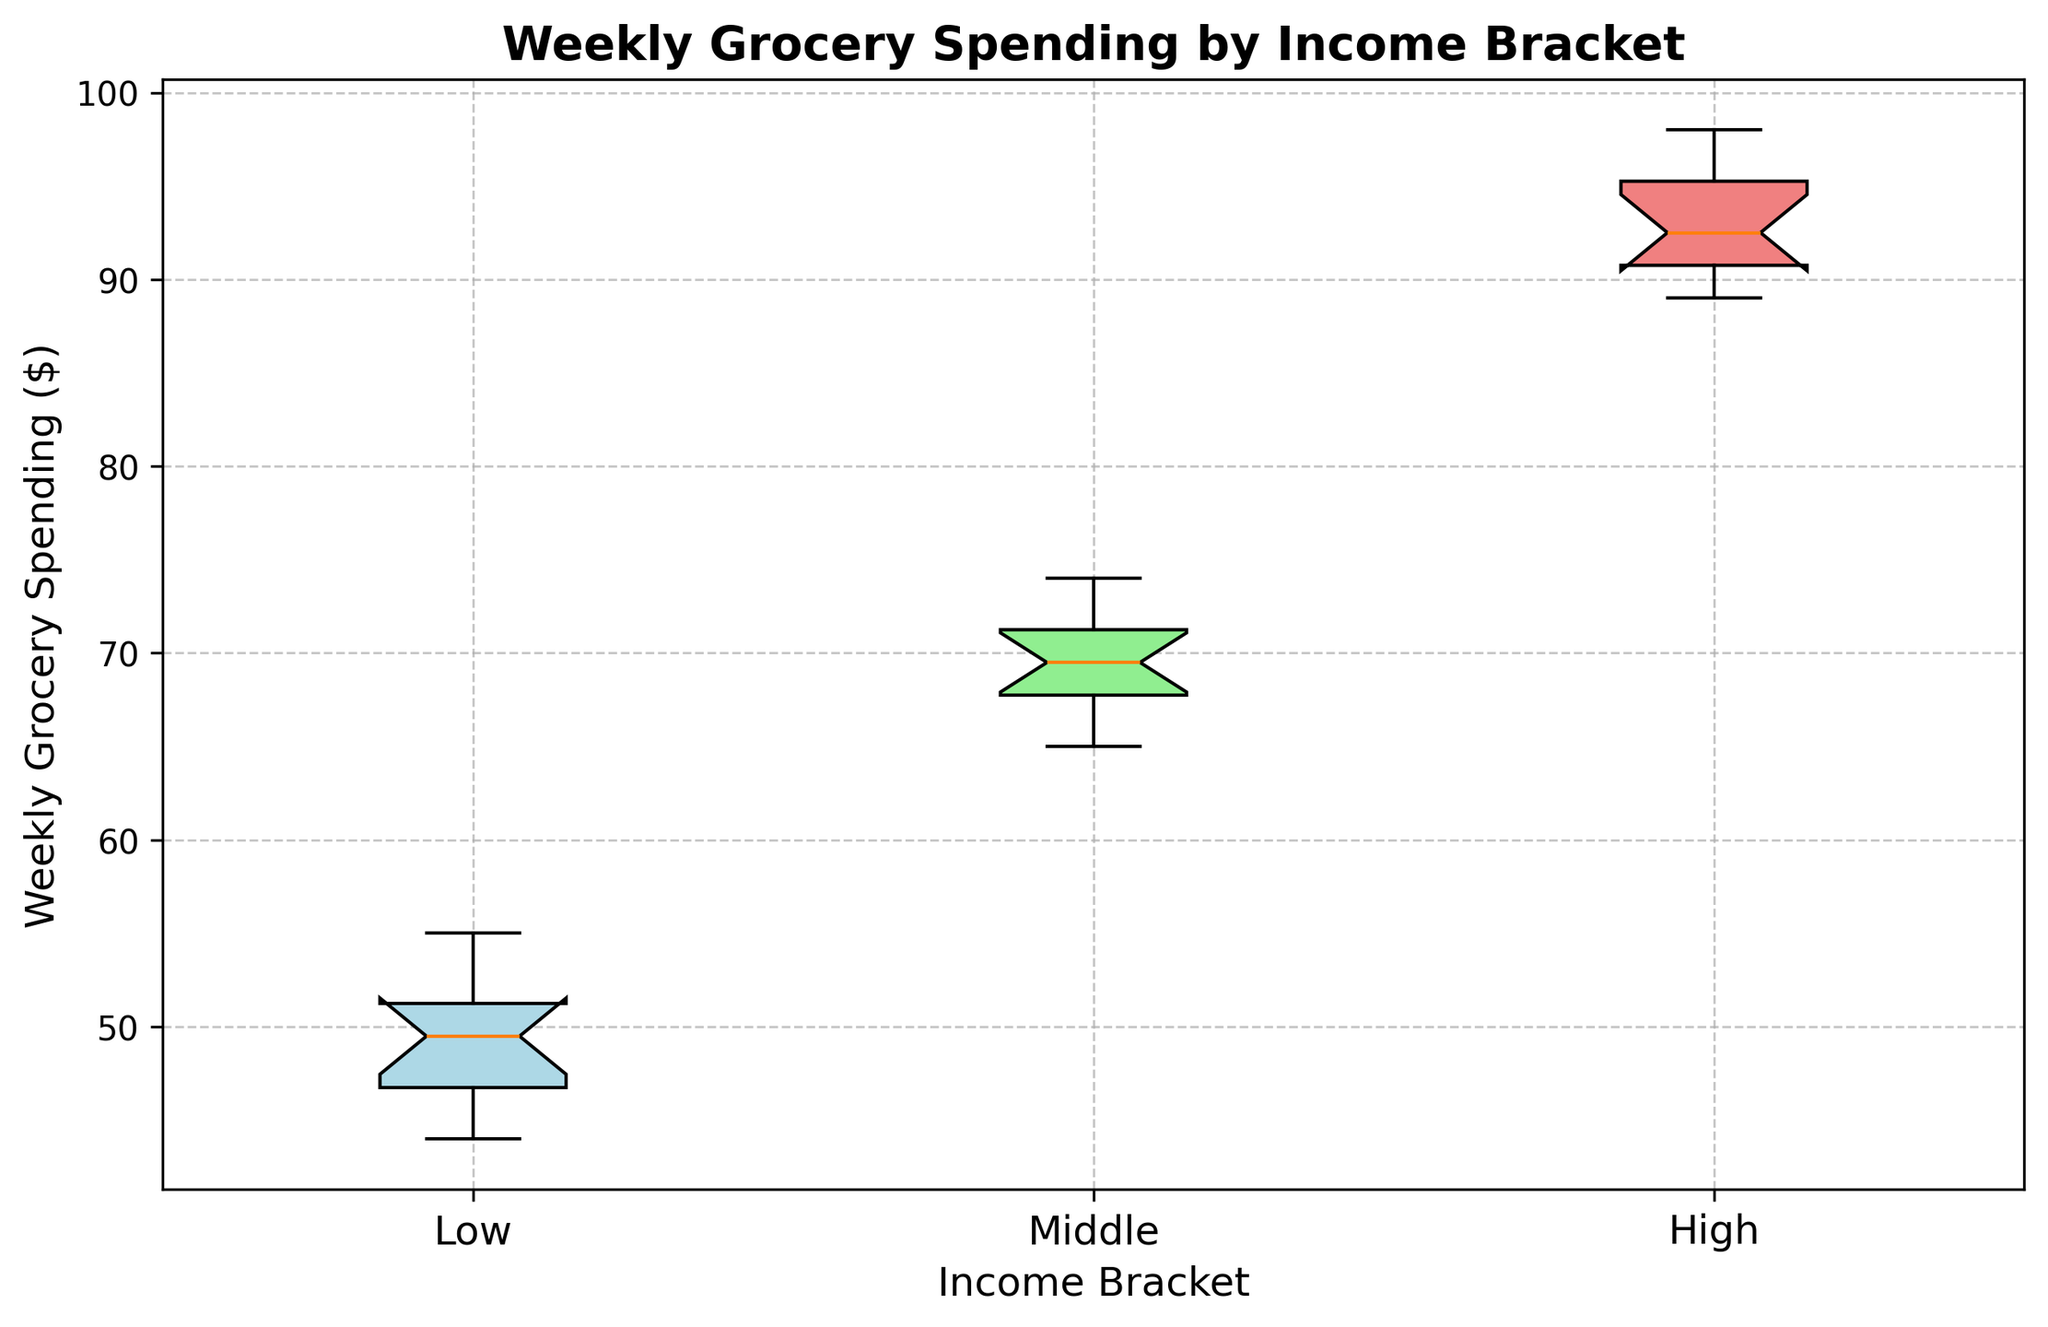What's the median weekly grocery spending for each income bracket? First, find the middle value for each group's data. If the number of data points is odd, the median is the middle value. If even, it's the average of the two middle values. For 'Low' (44, 45, 46, 47, 48, 49, 50, 50, 51, 52, 53, 55), the median is 49.5 (average of 49 and 50). For 'Middle' (65, 66, 67, 68, 68, 69, 70, 71, 71, 72, 73, 74), the median is 69.5. For 'High' (89, 90, 90, 91, 91, 92, 93, 94, 95, 96, 97, 98), the median is 92.5.
Answer: Low: 49.5, Middle: 69.5, High: 92.5 Which income bracket has the highest maximum spending? Look at the top values of the whiskers or outliers for each group. 'High' income bracket extends to 98, which is higher than the maximum values for 'Low' (55) and 'Middle' (74) income brackets.
Answer: High What's the interquartile range (IQR) for the Middle-income bracket? The IQR is the difference between the third quartile (Q3) and the first quartile (Q1). For the 'Middle' group, Q1 is approximately 67, and Q3 is approximately 72. So, IQR = 72 - 67.
Answer: 5 Compared to the Low-income bracket, is the range of weekly grocery spending larger for the High-income bracket? Calculate the range (maximum - minimum) for both. 'Low' has a range of 55 - 44 = 11. 'High' has a range of 98 - 89 = 9.
Answer: No Which income bracket has the smallest spread, or variance, in weekly grocery spending? Look at the box widths: the 'Low' income bracket has a narrower box compared to 'Middle' and 'High', indicating lower variability.
Answer: Low Which income bracket has the larger median weekly grocery spending, Middle or High? Examine the central line within each boxplot. The 'High' income bracket's median line is higher than that of the 'Middle' income bracket.
Answer: High Are there any outliers in the Low-income bracket? Check for any data points outside the whiskers. No such points exist for the 'Low' income bracket.
Answer: No What is the average minimum and maximum weekly grocery spending for all brackets combined? Calculate the minimums (Low: 44, Middle: 65, High: 89) and the maximums (Low: 55, Middle: 74, High: 98). Average minimum = (44 + 65 + 89) / 3 = 66. Average maximum = (55 + 74 + 98) / 3 = 75.67.
Answer: Min: 66, Max: 75.67 